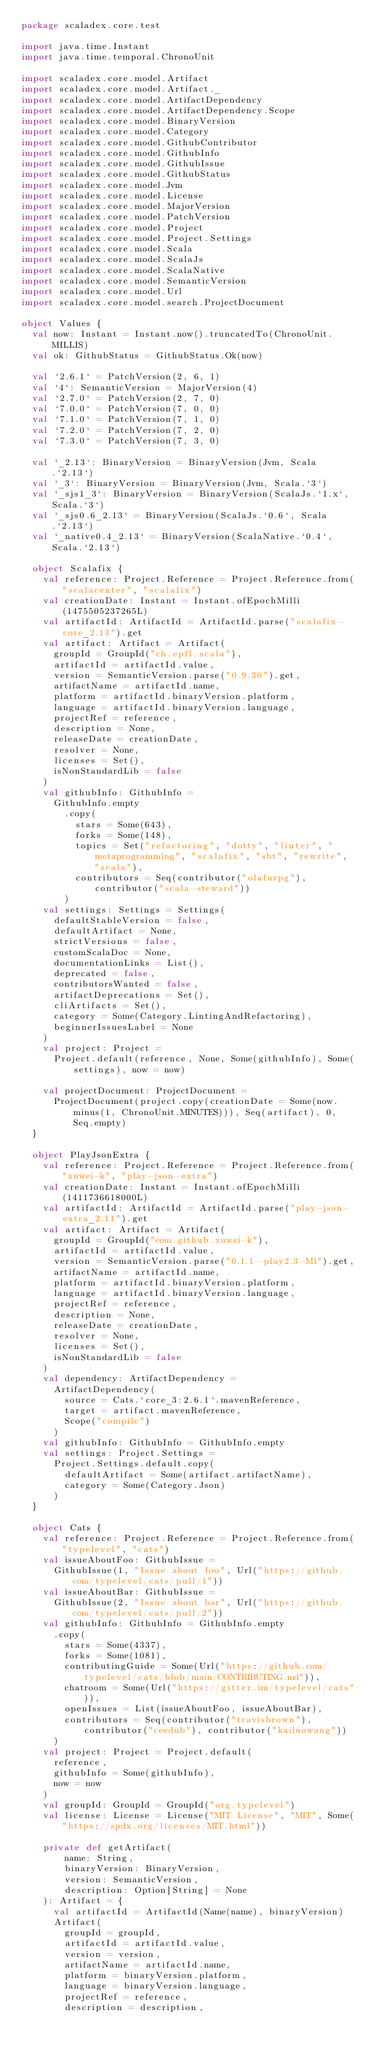Convert code to text. <code><loc_0><loc_0><loc_500><loc_500><_Scala_>package scaladex.core.test

import java.time.Instant
import java.time.temporal.ChronoUnit

import scaladex.core.model.Artifact
import scaladex.core.model.Artifact._
import scaladex.core.model.ArtifactDependency
import scaladex.core.model.ArtifactDependency.Scope
import scaladex.core.model.BinaryVersion
import scaladex.core.model.Category
import scaladex.core.model.GithubContributor
import scaladex.core.model.GithubInfo
import scaladex.core.model.GithubIssue
import scaladex.core.model.GithubStatus
import scaladex.core.model.Jvm
import scaladex.core.model.License
import scaladex.core.model.MajorVersion
import scaladex.core.model.PatchVersion
import scaladex.core.model.Project
import scaladex.core.model.Project.Settings
import scaladex.core.model.Scala
import scaladex.core.model.ScalaJs
import scaladex.core.model.ScalaNative
import scaladex.core.model.SemanticVersion
import scaladex.core.model.Url
import scaladex.core.model.search.ProjectDocument

object Values {
  val now: Instant = Instant.now().truncatedTo(ChronoUnit.MILLIS)
  val ok: GithubStatus = GithubStatus.Ok(now)

  val `2.6.1` = PatchVersion(2, 6, 1)
  val `4`: SemanticVersion = MajorVersion(4)
  val `2.7.0` = PatchVersion(2, 7, 0)
  val `7.0.0` = PatchVersion(7, 0, 0)
  val `7.1.0` = PatchVersion(7, 1, 0)
  val `7.2.0` = PatchVersion(7, 2, 0)
  val `7.3.0` = PatchVersion(7, 3, 0)

  val `_2.13`: BinaryVersion = BinaryVersion(Jvm, Scala.`2.13`)
  val `_3`: BinaryVersion = BinaryVersion(Jvm, Scala.`3`)
  val `_sjs1_3`: BinaryVersion = BinaryVersion(ScalaJs.`1.x`, Scala.`3`)
  val `_sjs0.6_2.13` = BinaryVersion(ScalaJs.`0.6`, Scala.`2.13`)
  val `_native0.4_2.13` = BinaryVersion(ScalaNative.`0.4`, Scala.`2.13`)

  object Scalafix {
    val reference: Project.Reference = Project.Reference.from("scalacenter", "scalafix")
    val creationDate: Instant = Instant.ofEpochMilli(1475505237265L)
    val artifactId: ArtifactId = ArtifactId.parse("scalafix-core_2.13").get
    val artifact: Artifact = Artifact(
      groupId = GroupId("ch.epfl.scala"),
      artifactId = artifactId.value,
      version = SemanticVersion.parse("0.9.30").get,
      artifactName = artifactId.name,
      platform = artifactId.binaryVersion.platform,
      language = artifactId.binaryVersion.language,
      projectRef = reference,
      description = None,
      releaseDate = creationDate,
      resolver = None,
      licenses = Set(),
      isNonStandardLib = false
    )
    val githubInfo: GithubInfo =
      GithubInfo.empty
        .copy(
          stars = Some(643),
          forks = Some(148),
          topics = Set("refactoring", "dotty", "linter", "metaprogramming", "scalafix", "sbt", "rewrite", "scala"),
          contributors = Seq(contributor("olafurpg"), contributor("scala-steward"))
        )
    val settings: Settings = Settings(
      defaultStableVersion = false,
      defaultArtifact = None,
      strictVersions = false,
      customScalaDoc = None,
      documentationLinks = List(),
      deprecated = false,
      contributorsWanted = false,
      artifactDeprecations = Set(),
      cliArtifacts = Set(),
      category = Some(Category.LintingAndRefactoring),
      beginnerIssuesLabel = None
    )
    val project: Project =
      Project.default(reference, None, Some(githubInfo), Some(settings), now = now)

    val projectDocument: ProjectDocument =
      ProjectDocument(project.copy(creationDate = Some(now.minus(1, ChronoUnit.MINUTES))), Seq(artifact), 0, Seq.empty)
  }

  object PlayJsonExtra {
    val reference: Project.Reference = Project.Reference.from("xuwei-k", "play-json-extra")
    val creationDate: Instant = Instant.ofEpochMilli(1411736618000L)
    val artifactId: ArtifactId = ArtifactId.parse("play-json-extra_2.11").get
    val artifact: Artifact = Artifact(
      groupId = GroupId("com.github.xuwei-k"),
      artifactId = artifactId.value,
      version = SemanticVersion.parse("0.1.1-play2.3-M1").get,
      artifactName = artifactId.name,
      platform = artifactId.binaryVersion.platform,
      language = artifactId.binaryVersion.language,
      projectRef = reference,
      description = None,
      releaseDate = creationDate,
      resolver = None,
      licenses = Set(),
      isNonStandardLib = false
    )
    val dependency: ArtifactDependency =
      ArtifactDependency(
        source = Cats.`core_3:2.6.1`.mavenReference,
        target = artifact.mavenReference,
        Scope("compile")
      )
    val githubInfo: GithubInfo = GithubInfo.empty
    val settings: Project.Settings =
      Project.Settings.default.copy(
        defaultArtifact = Some(artifact.artifactName),
        category = Some(Category.Json)
      )
  }

  object Cats {
    val reference: Project.Reference = Project.Reference.from("typelevel", "cats")
    val issueAboutFoo: GithubIssue =
      GithubIssue(1, "Issue about foo", Url("https://github.com/typelevel/cats/pull/1"))
    val issueAboutBar: GithubIssue =
      GithubIssue(2, "Issue about bar", Url("https://github.com/typelevel/cats/pull/2"))
    val githubInfo: GithubInfo = GithubInfo.empty
      .copy(
        stars = Some(4337),
        forks = Some(1081),
        contributingGuide = Some(Url("https://github.com/typelevel/cats/blob/main/CONTRIBUTING.md")),
        chatroom = Some(Url("https://gitter.im/typelevel/cats")),
        openIssues = List(issueAboutFoo, issueAboutBar),
        contributors = Seq(contributor("travisbrown"), contributor("ceedub"), contributor("kailuowang"))
      )
    val project: Project = Project.default(
      reference,
      githubInfo = Some(githubInfo),
      now = now
    )
    val groupId: GroupId = GroupId("org.typelevel")
    val license: License = License("MIT License", "MIT", Some("https://spdx.org/licenses/MIT.html"))

    private def getArtifact(
        name: String,
        binaryVersion: BinaryVersion,
        version: SemanticVersion,
        description: Option[String] = None
    ): Artifact = {
      val artifactId = ArtifactId(Name(name), binaryVersion)
      Artifact(
        groupId = groupId,
        artifactId = artifactId.value,
        version = version,
        artifactName = artifactId.name,
        platform = binaryVersion.platform,
        language = binaryVersion.language,
        projectRef = reference,
        description = description,</code> 